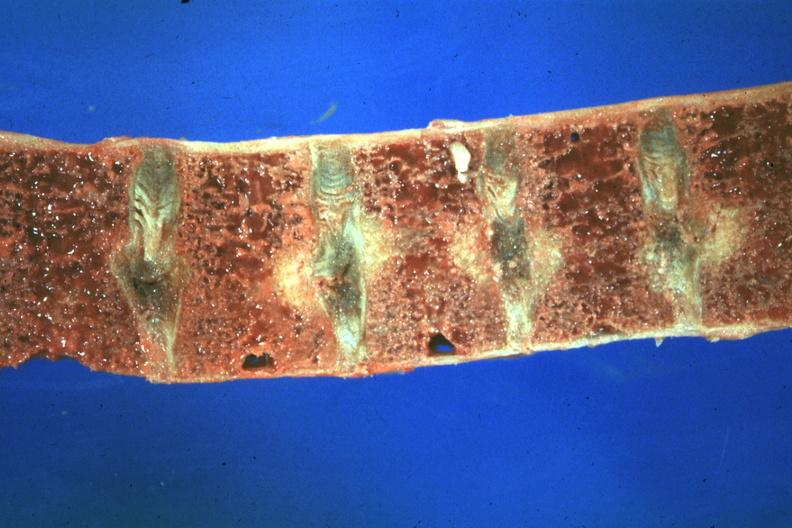s joints present?
Answer the question using a single word or phrase. Yes 